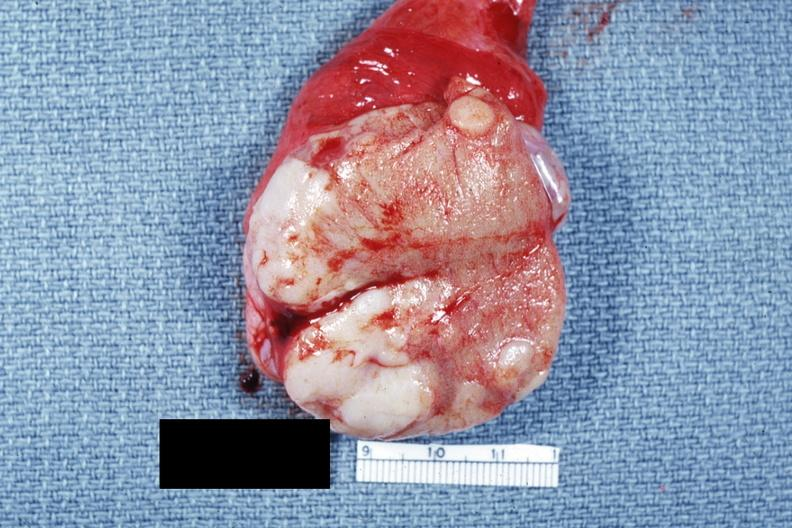what does this image show?
Answer the question using a single word or phrase. Close-up tumor well shown primary not stated said to be adenocarcinoma 